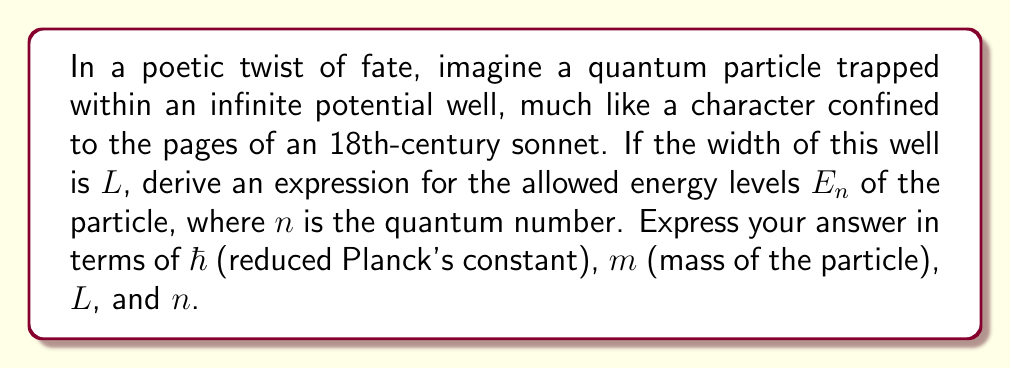Solve this math problem. Let's approach this step-by-step, like analyzing the structure of a poem:

1) The time-independent Schrödinger equation for a particle in a one-dimensional potential well is:

   $$-\frac{\hbar^2}{2m}\frac{d^2\psi}{dx^2} + V(x)\psi = E\psi$$

2) For an infinite potential well, $V(x) = 0$ inside the well $(0 < x < L)$ and $V(x) = \infty$ elsewhere.

3) Inside the well, the equation simplifies to:

   $$-\frac{\hbar^2}{2m}\frac{d^2\psi}{dx^2} = E\psi$$

4) This has the general solution:

   $$\psi(x) = A\sin(kx) + B\cos(kx)$$

   where $k = \sqrt{\frac{2mE}{\hbar^2}}$

5) The boundary conditions require $\psi(0) = \psi(L) = 0$, which leads to:

   $\psi(0) = 0 \implies B = 0$
   $\psi(L) = 0 \implies A\sin(kL) = 0$

6) For non-trivial solutions, $\sin(kL) = 0$, which means:

   $$kL = n\pi, \quad n = 1, 2, 3, ...$$

7) Substituting the expression for $k$:

   $$\sqrt{\frac{2mE}{\hbar^2}}L = n\pi$$

8) Solving for $E$:

   $$E = \frac{n^2\pi^2\hbar^2}{2mL^2}$$

This expression, like a well-crafted verse, encapsulates the discrete nature of quantum energy levels.
Answer: $E_n = \frac{n^2\pi^2\hbar^2}{2mL^2}$ 